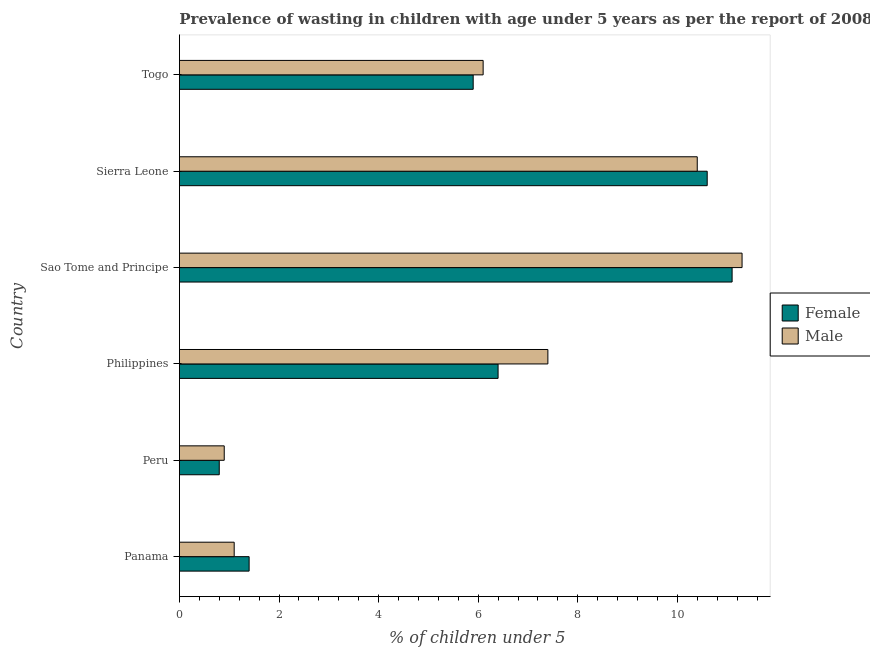How many different coloured bars are there?
Ensure brevity in your answer.  2. How many groups of bars are there?
Make the answer very short. 6. Are the number of bars per tick equal to the number of legend labels?
Offer a very short reply. Yes. How many bars are there on the 1st tick from the top?
Your answer should be compact. 2. How many bars are there on the 2nd tick from the bottom?
Provide a short and direct response. 2. What is the label of the 4th group of bars from the top?
Ensure brevity in your answer.  Philippines. What is the percentage of undernourished male children in Peru?
Offer a very short reply. 0.9. Across all countries, what is the maximum percentage of undernourished female children?
Your response must be concise. 11.1. Across all countries, what is the minimum percentage of undernourished male children?
Make the answer very short. 0.9. In which country was the percentage of undernourished female children maximum?
Your response must be concise. Sao Tome and Principe. In which country was the percentage of undernourished female children minimum?
Your answer should be compact. Peru. What is the total percentage of undernourished male children in the graph?
Your response must be concise. 37.2. What is the difference between the percentage of undernourished male children in Sao Tome and Principe and that in Togo?
Your answer should be very brief. 5.2. What is the difference between the percentage of undernourished female children in Philippines and the percentage of undernourished male children in Togo?
Provide a succinct answer. 0.3. What is the difference between the percentage of undernourished female children and percentage of undernourished male children in Peru?
Your response must be concise. -0.1. In how many countries, is the percentage of undernourished female children greater than 10.4 %?
Make the answer very short. 2. What is the ratio of the percentage of undernourished male children in Sao Tome and Principe to that in Togo?
Your answer should be compact. 1.85. Is the percentage of undernourished male children in Peru less than that in Sierra Leone?
Your response must be concise. Yes. Is the difference between the percentage of undernourished female children in Sao Tome and Principe and Togo greater than the difference between the percentage of undernourished male children in Sao Tome and Principe and Togo?
Make the answer very short. No. What is the difference between the highest and the second highest percentage of undernourished female children?
Give a very brief answer. 0.5. What does the 1st bar from the top in Peru represents?
Your answer should be very brief. Male. What does the 2nd bar from the bottom in Peru represents?
Give a very brief answer. Male. Does the graph contain grids?
Provide a short and direct response. No. Where does the legend appear in the graph?
Offer a terse response. Center right. How many legend labels are there?
Your answer should be compact. 2. What is the title of the graph?
Keep it short and to the point. Prevalence of wasting in children with age under 5 years as per the report of 2008. What is the label or title of the X-axis?
Make the answer very short.  % of children under 5. What is the label or title of the Y-axis?
Offer a terse response. Country. What is the  % of children under 5 in Female in Panama?
Provide a short and direct response. 1.4. What is the  % of children under 5 in Male in Panama?
Your answer should be compact. 1.1. What is the  % of children under 5 of Female in Peru?
Give a very brief answer. 0.8. What is the  % of children under 5 in Male in Peru?
Your answer should be very brief. 0.9. What is the  % of children under 5 in Female in Philippines?
Make the answer very short. 6.4. What is the  % of children under 5 in Male in Philippines?
Keep it short and to the point. 7.4. What is the  % of children under 5 in Female in Sao Tome and Principe?
Offer a terse response. 11.1. What is the  % of children under 5 of Male in Sao Tome and Principe?
Your response must be concise. 11.3. What is the  % of children under 5 in Female in Sierra Leone?
Make the answer very short. 10.6. What is the  % of children under 5 in Male in Sierra Leone?
Your answer should be very brief. 10.4. What is the  % of children under 5 of Female in Togo?
Offer a terse response. 5.9. What is the  % of children under 5 in Male in Togo?
Provide a short and direct response. 6.1. Across all countries, what is the maximum  % of children under 5 in Female?
Your answer should be compact. 11.1. Across all countries, what is the maximum  % of children under 5 in Male?
Your answer should be very brief. 11.3. Across all countries, what is the minimum  % of children under 5 of Female?
Your answer should be very brief. 0.8. Across all countries, what is the minimum  % of children under 5 in Male?
Your answer should be very brief. 0.9. What is the total  % of children under 5 of Female in the graph?
Provide a short and direct response. 36.2. What is the total  % of children under 5 in Male in the graph?
Make the answer very short. 37.2. What is the difference between the  % of children under 5 of Female in Panama and that in Peru?
Your answer should be compact. 0.6. What is the difference between the  % of children under 5 of Male in Panama and that in Philippines?
Provide a short and direct response. -6.3. What is the difference between the  % of children under 5 in Female in Panama and that in Sao Tome and Principe?
Ensure brevity in your answer.  -9.7. What is the difference between the  % of children under 5 of Female in Panama and that in Sierra Leone?
Give a very brief answer. -9.2. What is the difference between the  % of children under 5 in Female in Panama and that in Togo?
Your answer should be compact. -4.5. What is the difference between the  % of children under 5 of Female in Peru and that in Sao Tome and Principe?
Make the answer very short. -10.3. What is the difference between the  % of children under 5 in Male in Peru and that in Sao Tome and Principe?
Your answer should be compact. -10.4. What is the difference between the  % of children under 5 of Female in Peru and that in Sierra Leone?
Your response must be concise. -9.8. What is the difference between the  % of children under 5 of Female in Peru and that in Togo?
Your answer should be compact. -5.1. What is the difference between the  % of children under 5 of Male in Philippines and that in Sierra Leone?
Your answer should be compact. -3. What is the difference between the  % of children under 5 in Female in Philippines and that in Togo?
Keep it short and to the point. 0.5. What is the difference between the  % of children under 5 in Male in Philippines and that in Togo?
Provide a short and direct response. 1.3. What is the difference between the  % of children under 5 in Male in Sao Tome and Principe and that in Sierra Leone?
Your answer should be compact. 0.9. What is the difference between the  % of children under 5 in Female in Sierra Leone and that in Togo?
Your answer should be compact. 4.7. What is the difference between the  % of children under 5 of Male in Sierra Leone and that in Togo?
Your answer should be very brief. 4.3. What is the difference between the  % of children under 5 in Female in Panama and the  % of children under 5 in Male in Peru?
Ensure brevity in your answer.  0.5. What is the difference between the  % of children under 5 in Female in Panama and the  % of children under 5 in Male in Philippines?
Your response must be concise. -6. What is the difference between the  % of children under 5 of Female in Panama and the  % of children under 5 of Male in Sao Tome and Principe?
Provide a succinct answer. -9.9. What is the difference between the  % of children under 5 in Female in Panama and the  % of children under 5 in Male in Sierra Leone?
Make the answer very short. -9. What is the difference between the  % of children under 5 of Female in Peru and the  % of children under 5 of Male in Sierra Leone?
Keep it short and to the point. -9.6. What is the difference between the  % of children under 5 in Female in Peru and the  % of children under 5 in Male in Togo?
Offer a terse response. -5.3. What is the difference between the  % of children under 5 of Female in Philippines and the  % of children under 5 of Male in Sao Tome and Principe?
Your answer should be very brief. -4.9. What is the difference between the  % of children under 5 of Female in Philippines and the  % of children under 5 of Male in Togo?
Make the answer very short. 0.3. What is the difference between the  % of children under 5 in Female in Sao Tome and Principe and the  % of children under 5 in Male in Sierra Leone?
Offer a very short reply. 0.7. What is the difference between the  % of children under 5 in Female in Sao Tome and Principe and the  % of children under 5 in Male in Togo?
Give a very brief answer. 5. What is the average  % of children under 5 in Female per country?
Give a very brief answer. 6.03. What is the difference between the  % of children under 5 of Female and  % of children under 5 of Male in Sao Tome and Principe?
Ensure brevity in your answer.  -0.2. What is the difference between the  % of children under 5 of Female and  % of children under 5 of Male in Togo?
Give a very brief answer. -0.2. What is the ratio of the  % of children under 5 in Male in Panama to that in Peru?
Provide a short and direct response. 1.22. What is the ratio of the  % of children under 5 of Female in Panama to that in Philippines?
Provide a short and direct response. 0.22. What is the ratio of the  % of children under 5 in Male in Panama to that in Philippines?
Keep it short and to the point. 0.15. What is the ratio of the  % of children under 5 in Female in Panama to that in Sao Tome and Principe?
Your answer should be compact. 0.13. What is the ratio of the  % of children under 5 in Male in Panama to that in Sao Tome and Principe?
Provide a short and direct response. 0.1. What is the ratio of the  % of children under 5 in Female in Panama to that in Sierra Leone?
Your answer should be very brief. 0.13. What is the ratio of the  % of children under 5 of Male in Panama to that in Sierra Leone?
Make the answer very short. 0.11. What is the ratio of the  % of children under 5 in Female in Panama to that in Togo?
Your response must be concise. 0.24. What is the ratio of the  % of children under 5 of Male in Panama to that in Togo?
Make the answer very short. 0.18. What is the ratio of the  % of children under 5 of Male in Peru to that in Philippines?
Your answer should be very brief. 0.12. What is the ratio of the  % of children under 5 of Female in Peru to that in Sao Tome and Principe?
Keep it short and to the point. 0.07. What is the ratio of the  % of children under 5 of Male in Peru to that in Sao Tome and Principe?
Make the answer very short. 0.08. What is the ratio of the  % of children under 5 of Female in Peru to that in Sierra Leone?
Your answer should be very brief. 0.08. What is the ratio of the  % of children under 5 of Male in Peru to that in Sierra Leone?
Your answer should be very brief. 0.09. What is the ratio of the  % of children under 5 of Female in Peru to that in Togo?
Provide a short and direct response. 0.14. What is the ratio of the  % of children under 5 in Male in Peru to that in Togo?
Offer a very short reply. 0.15. What is the ratio of the  % of children under 5 in Female in Philippines to that in Sao Tome and Principe?
Provide a short and direct response. 0.58. What is the ratio of the  % of children under 5 of Male in Philippines to that in Sao Tome and Principe?
Give a very brief answer. 0.65. What is the ratio of the  % of children under 5 of Female in Philippines to that in Sierra Leone?
Your answer should be very brief. 0.6. What is the ratio of the  % of children under 5 of Male in Philippines to that in Sierra Leone?
Give a very brief answer. 0.71. What is the ratio of the  % of children under 5 of Female in Philippines to that in Togo?
Keep it short and to the point. 1.08. What is the ratio of the  % of children under 5 of Male in Philippines to that in Togo?
Offer a very short reply. 1.21. What is the ratio of the  % of children under 5 of Female in Sao Tome and Principe to that in Sierra Leone?
Your answer should be compact. 1.05. What is the ratio of the  % of children under 5 of Male in Sao Tome and Principe to that in Sierra Leone?
Offer a terse response. 1.09. What is the ratio of the  % of children under 5 in Female in Sao Tome and Principe to that in Togo?
Offer a very short reply. 1.88. What is the ratio of the  % of children under 5 in Male in Sao Tome and Principe to that in Togo?
Keep it short and to the point. 1.85. What is the ratio of the  % of children under 5 of Female in Sierra Leone to that in Togo?
Keep it short and to the point. 1.8. What is the ratio of the  % of children under 5 in Male in Sierra Leone to that in Togo?
Provide a succinct answer. 1.7. What is the difference between the highest and the lowest  % of children under 5 in Male?
Give a very brief answer. 10.4. 